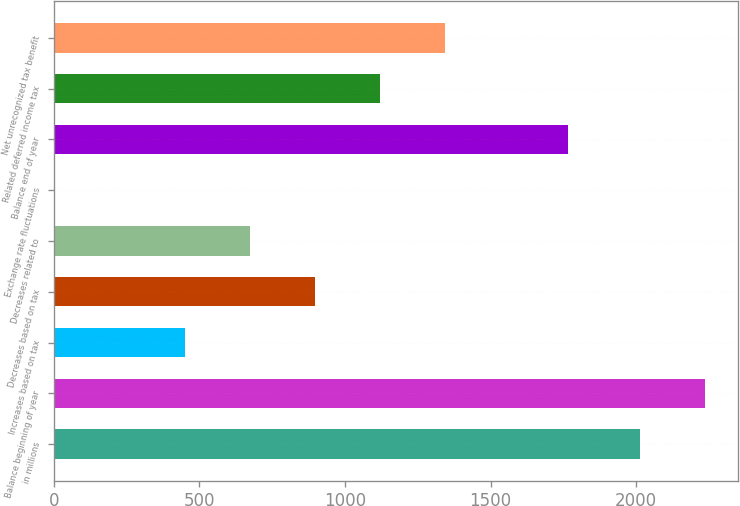<chart> <loc_0><loc_0><loc_500><loc_500><bar_chart><fcel>in millions<fcel>Balance beginning of year<fcel>Increases based on tax<fcel>Decreases based on tax<fcel>Decreases related to<fcel>Exchange rate fluctuations<fcel>Balance end of year<fcel>Related deferred income tax<fcel>Net unrecognized tax benefit<nl><fcel>2013<fcel>2237<fcel>451.4<fcel>897.8<fcel>674.6<fcel>5<fcel>1765<fcel>1121<fcel>1344.2<nl></chart> 